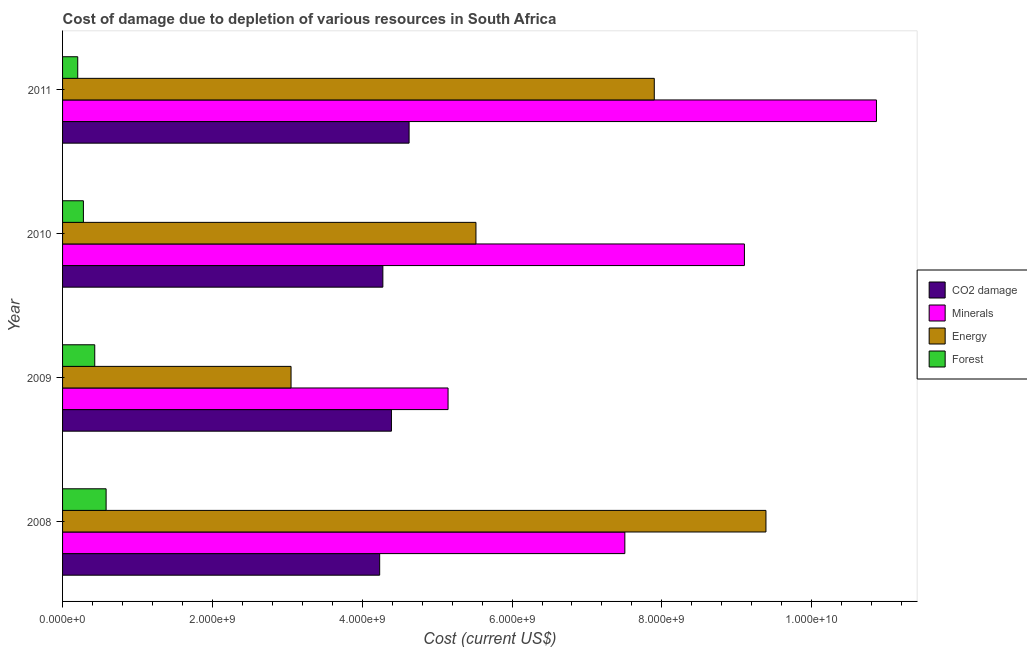How many different coloured bars are there?
Ensure brevity in your answer.  4. How many groups of bars are there?
Provide a short and direct response. 4. Are the number of bars on each tick of the Y-axis equal?
Your answer should be very brief. Yes. In how many cases, is the number of bars for a given year not equal to the number of legend labels?
Provide a short and direct response. 0. What is the cost of damage due to depletion of forests in 2009?
Offer a very short reply. 4.30e+08. Across all years, what is the maximum cost of damage due to depletion of energy?
Ensure brevity in your answer.  9.39e+09. Across all years, what is the minimum cost of damage due to depletion of energy?
Offer a terse response. 3.05e+09. What is the total cost of damage due to depletion of minerals in the graph?
Make the answer very short. 3.26e+1. What is the difference between the cost of damage due to depletion of energy in 2009 and that in 2011?
Offer a very short reply. -4.85e+09. What is the difference between the cost of damage due to depletion of minerals in 2011 and the cost of damage due to depletion of energy in 2008?
Your answer should be very brief. 1.48e+09. What is the average cost of damage due to depletion of minerals per year?
Offer a very short reply. 8.15e+09. In the year 2009, what is the difference between the cost of damage due to depletion of coal and cost of damage due to depletion of energy?
Offer a very short reply. 1.34e+09. In how many years, is the cost of damage due to depletion of energy greater than 1200000000 US$?
Keep it short and to the point. 4. What is the ratio of the cost of damage due to depletion of minerals in 2008 to that in 2011?
Keep it short and to the point. 0.69. What is the difference between the highest and the second highest cost of damage due to depletion of minerals?
Provide a succinct answer. 1.76e+09. What is the difference between the highest and the lowest cost of damage due to depletion of coal?
Your response must be concise. 3.93e+08. In how many years, is the cost of damage due to depletion of forests greater than the average cost of damage due to depletion of forests taken over all years?
Your response must be concise. 2. Is the sum of the cost of damage due to depletion of minerals in 2010 and 2011 greater than the maximum cost of damage due to depletion of energy across all years?
Your answer should be compact. Yes. Is it the case that in every year, the sum of the cost of damage due to depletion of coal and cost of damage due to depletion of minerals is greater than the sum of cost of damage due to depletion of forests and cost of damage due to depletion of energy?
Keep it short and to the point. Yes. What does the 2nd bar from the top in 2011 represents?
Make the answer very short. Energy. What does the 1st bar from the bottom in 2011 represents?
Your answer should be very brief. CO2 damage. Is it the case that in every year, the sum of the cost of damage due to depletion of coal and cost of damage due to depletion of minerals is greater than the cost of damage due to depletion of energy?
Your answer should be very brief. Yes. How many bars are there?
Your answer should be very brief. 16. How many years are there in the graph?
Provide a short and direct response. 4. What is the difference between two consecutive major ticks on the X-axis?
Ensure brevity in your answer.  2.00e+09. Are the values on the major ticks of X-axis written in scientific E-notation?
Offer a very short reply. Yes. Where does the legend appear in the graph?
Make the answer very short. Center right. How are the legend labels stacked?
Your response must be concise. Vertical. What is the title of the graph?
Offer a very short reply. Cost of damage due to depletion of various resources in South Africa . What is the label or title of the X-axis?
Give a very brief answer. Cost (current US$). What is the Cost (current US$) of CO2 damage in 2008?
Offer a very short reply. 4.23e+09. What is the Cost (current US$) of Minerals in 2008?
Your response must be concise. 7.51e+09. What is the Cost (current US$) in Energy in 2008?
Make the answer very short. 9.39e+09. What is the Cost (current US$) of Forest in 2008?
Keep it short and to the point. 5.81e+08. What is the Cost (current US$) of CO2 damage in 2009?
Ensure brevity in your answer.  4.39e+09. What is the Cost (current US$) of Minerals in 2009?
Offer a very short reply. 5.15e+09. What is the Cost (current US$) of Energy in 2009?
Keep it short and to the point. 3.05e+09. What is the Cost (current US$) of Forest in 2009?
Provide a succinct answer. 4.30e+08. What is the Cost (current US$) of CO2 damage in 2010?
Make the answer very short. 4.28e+09. What is the Cost (current US$) in Minerals in 2010?
Your response must be concise. 9.10e+09. What is the Cost (current US$) of Energy in 2010?
Offer a very short reply. 5.52e+09. What is the Cost (current US$) of Forest in 2010?
Your answer should be very brief. 2.78e+08. What is the Cost (current US$) in CO2 damage in 2011?
Provide a short and direct response. 4.63e+09. What is the Cost (current US$) in Minerals in 2011?
Keep it short and to the point. 1.09e+1. What is the Cost (current US$) in Energy in 2011?
Make the answer very short. 7.90e+09. What is the Cost (current US$) in Forest in 2011?
Offer a very short reply. 2.02e+08. Across all years, what is the maximum Cost (current US$) of CO2 damage?
Keep it short and to the point. 4.63e+09. Across all years, what is the maximum Cost (current US$) of Minerals?
Keep it short and to the point. 1.09e+1. Across all years, what is the maximum Cost (current US$) of Energy?
Keep it short and to the point. 9.39e+09. Across all years, what is the maximum Cost (current US$) of Forest?
Your response must be concise. 5.81e+08. Across all years, what is the minimum Cost (current US$) in CO2 damage?
Provide a succinct answer. 4.23e+09. Across all years, what is the minimum Cost (current US$) of Minerals?
Keep it short and to the point. 5.15e+09. Across all years, what is the minimum Cost (current US$) in Energy?
Offer a terse response. 3.05e+09. Across all years, what is the minimum Cost (current US$) of Forest?
Give a very brief answer. 2.02e+08. What is the total Cost (current US$) of CO2 damage in the graph?
Offer a terse response. 1.75e+1. What is the total Cost (current US$) of Minerals in the graph?
Provide a short and direct response. 3.26e+1. What is the total Cost (current US$) in Energy in the graph?
Keep it short and to the point. 2.59e+1. What is the total Cost (current US$) of Forest in the graph?
Make the answer very short. 1.49e+09. What is the difference between the Cost (current US$) in CO2 damage in 2008 and that in 2009?
Your answer should be very brief. -1.57e+08. What is the difference between the Cost (current US$) of Minerals in 2008 and that in 2009?
Offer a very short reply. 2.36e+09. What is the difference between the Cost (current US$) in Energy in 2008 and that in 2009?
Offer a very short reply. 6.34e+09. What is the difference between the Cost (current US$) of Forest in 2008 and that in 2009?
Make the answer very short. 1.52e+08. What is the difference between the Cost (current US$) of CO2 damage in 2008 and that in 2010?
Offer a terse response. -4.26e+07. What is the difference between the Cost (current US$) of Minerals in 2008 and that in 2010?
Give a very brief answer. -1.60e+09. What is the difference between the Cost (current US$) of Energy in 2008 and that in 2010?
Offer a very short reply. 3.87e+09. What is the difference between the Cost (current US$) of Forest in 2008 and that in 2010?
Provide a short and direct response. 3.03e+08. What is the difference between the Cost (current US$) in CO2 damage in 2008 and that in 2011?
Keep it short and to the point. -3.93e+08. What is the difference between the Cost (current US$) in Minerals in 2008 and that in 2011?
Ensure brevity in your answer.  -3.36e+09. What is the difference between the Cost (current US$) of Energy in 2008 and that in 2011?
Provide a succinct answer. 1.49e+09. What is the difference between the Cost (current US$) of Forest in 2008 and that in 2011?
Ensure brevity in your answer.  3.79e+08. What is the difference between the Cost (current US$) in CO2 damage in 2009 and that in 2010?
Your response must be concise. 1.14e+08. What is the difference between the Cost (current US$) of Minerals in 2009 and that in 2010?
Provide a succinct answer. -3.96e+09. What is the difference between the Cost (current US$) in Energy in 2009 and that in 2010?
Your answer should be compact. -2.47e+09. What is the difference between the Cost (current US$) in Forest in 2009 and that in 2010?
Your answer should be very brief. 1.51e+08. What is the difference between the Cost (current US$) of CO2 damage in 2009 and that in 2011?
Give a very brief answer. -2.36e+08. What is the difference between the Cost (current US$) in Minerals in 2009 and that in 2011?
Offer a terse response. -5.72e+09. What is the difference between the Cost (current US$) of Energy in 2009 and that in 2011?
Provide a short and direct response. -4.85e+09. What is the difference between the Cost (current US$) of Forest in 2009 and that in 2011?
Your answer should be compact. 2.27e+08. What is the difference between the Cost (current US$) in CO2 damage in 2010 and that in 2011?
Provide a succinct answer. -3.50e+08. What is the difference between the Cost (current US$) of Minerals in 2010 and that in 2011?
Your answer should be very brief. -1.76e+09. What is the difference between the Cost (current US$) of Energy in 2010 and that in 2011?
Offer a very short reply. -2.38e+09. What is the difference between the Cost (current US$) of Forest in 2010 and that in 2011?
Ensure brevity in your answer.  7.59e+07. What is the difference between the Cost (current US$) of CO2 damage in 2008 and the Cost (current US$) of Minerals in 2009?
Make the answer very short. -9.13e+08. What is the difference between the Cost (current US$) in CO2 damage in 2008 and the Cost (current US$) in Energy in 2009?
Your answer should be very brief. 1.18e+09. What is the difference between the Cost (current US$) in CO2 damage in 2008 and the Cost (current US$) in Forest in 2009?
Your answer should be very brief. 3.80e+09. What is the difference between the Cost (current US$) in Minerals in 2008 and the Cost (current US$) in Energy in 2009?
Ensure brevity in your answer.  4.46e+09. What is the difference between the Cost (current US$) in Minerals in 2008 and the Cost (current US$) in Forest in 2009?
Your response must be concise. 7.08e+09. What is the difference between the Cost (current US$) of Energy in 2008 and the Cost (current US$) of Forest in 2009?
Ensure brevity in your answer.  8.96e+09. What is the difference between the Cost (current US$) of CO2 damage in 2008 and the Cost (current US$) of Minerals in 2010?
Give a very brief answer. -4.87e+09. What is the difference between the Cost (current US$) of CO2 damage in 2008 and the Cost (current US$) of Energy in 2010?
Provide a succinct answer. -1.29e+09. What is the difference between the Cost (current US$) in CO2 damage in 2008 and the Cost (current US$) in Forest in 2010?
Offer a terse response. 3.95e+09. What is the difference between the Cost (current US$) in Minerals in 2008 and the Cost (current US$) in Energy in 2010?
Your answer should be very brief. 1.99e+09. What is the difference between the Cost (current US$) in Minerals in 2008 and the Cost (current US$) in Forest in 2010?
Your answer should be compact. 7.23e+09. What is the difference between the Cost (current US$) of Energy in 2008 and the Cost (current US$) of Forest in 2010?
Offer a terse response. 9.11e+09. What is the difference between the Cost (current US$) of CO2 damage in 2008 and the Cost (current US$) of Minerals in 2011?
Offer a very short reply. -6.63e+09. What is the difference between the Cost (current US$) of CO2 damage in 2008 and the Cost (current US$) of Energy in 2011?
Ensure brevity in your answer.  -3.67e+09. What is the difference between the Cost (current US$) of CO2 damage in 2008 and the Cost (current US$) of Forest in 2011?
Provide a succinct answer. 4.03e+09. What is the difference between the Cost (current US$) in Minerals in 2008 and the Cost (current US$) in Energy in 2011?
Provide a succinct answer. -3.93e+08. What is the difference between the Cost (current US$) in Minerals in 2008 and the Cost (current US$) in Forest in 2011?
Your response must be concise. 7.30e+09. What is the difference between the Cost (current US$) in Energy in 2008 and the Cost (current US$) in Forest in 2011?
Ensure brevity in your answer.  9.19e+09. What is the difference between the Cost (current US$) in CO2 damage in 2009 and the Cost (current US$) in Minerals in 2010?
Your answer should be very brief. -4.71e+09. What is the difference between the Cost (current US$) of CO2 damage in 2009 and the Cost (current US$) of Energy in 2010?
Make the answer very short. -1.13e+09. What is the difference between the Cost (current US$) of CO2 damage in 2009 and the Cost (current US$) of Forest in 2010?
Your response must be concise. 4.11e+09. What is the difference between the Cost (current US$) of Minerals in 2009 and the Cost (current US$) of Energy in 2010?
Give a very brief answer. -3.72e+08. What is the difference between the Cost (current US$) in Minerals in 2009 and the Cost (current US$) in Forest in 2010?
Keep it short and to the point. 4.87e+09. What is the difference between the Cost (current US$) in Energy in 2009 and the Cost (current US$) in Forest in 2010?
Keep it short and to the point. 2.77e+09. What is the difference between the Cost (current US$) in CO2 damage in 2009 and the Cost (current US$) in Minerals in 2011?
Provide a succinct answer. -6.47e+09. What is the difference between the Cost (current US$) of CO2 damage in 2009 and the Cost (current US$) of Energy in 2011?
Make the answer very short. -3.51e+09. What is the difference between the Cost (current US$) in CO2 damage in 2009 and the Cost (current US$) in Forest in 2011?
Ensure brevity in your answer.  4.19e+09. What is the difference between the Cost (current US$) in Minerals in 2009 and the Cost (current US$) in Energy in 2011?
Give a very brief answer. -2.75e+09. What is the difference between the Cost (current US$) in Minerals in 2009 and the Cost (current US$) in Forest in 2011?
Provide a succinct answer. 4.94e+09. What is the difference between the Cost (current US$) of Energy in 2009 and the Cost (current US$) of Forest in 2011?
Give a very brief answer. 2.85e+09. What is the difference between the Cost (current US$) of CO2 damage in 2010 and the Cost (current US$) of Minerals in 2011?
Provide a short and direct response. -6.59e+09. What is the difference between the Cost (current US$) of CO2 damage in 2010 and the Cost (current US$) of Energy in 2011?
Provide a short and direct response. -3.62e+09. What is the difference between the Cost (current US$) of CO2 damage in 2010 and the Cost (current US$) of Forest in 2011?
Your answer should be very brief. 4.07e+09. What is the difference between the Cost (current US$) in Minerals in 2010 and the Cost (current US$) in Energy in 2011?
Make the answer very short. 1.20e+09. What is the difference between the Cost (current US$) in Minerals in 2010 and the Cost (current US$) in Forest in 2011?
Your answer should be very brief. 8.90e+09. What is the difference between the Cost (current US$) in Energy in 2010 and the Cost (current US$) in Forest in 2011?
Ensure brevity in your answer.  5.32e+09. What is the average Cost (current US$) in CO2 damage per year?
Your answer should be compact. 4.38e+09. What is the average Cost (current US$) of Minerals per year?
Provide a succinct answer. 8.15e+09. What is the average Cost (current US$) in Energy per year?
Your answer should be very brief. 6.46e+09. What is the average Cost (current US$) of Forest per year?
Make the answer very short. 3.73e+08. In the year 2008, what is the difference between the Cost (current US$) in CO2 damage and Cost (current US$) in Minerals?
Offer a very short reply. -3.27e+09. In the year 2008, what is the difference between the Cost (current US$) of CO2 damage and Cost (current US$) of Energy?
Provide a short and direct response. -5.16e+09. In the year 2008, what is the difference between the Cost (current US$) of CO2 damage and Cost (current US$) of Forest?
Provide a short and direct response. 3.65e+09. In the year 2008, what is the difference between the Cost (current US$) of Minerals and Cost (current US$) of Energy?
Provide a succinct answer. -1.88e+09. In the year 2008, what is the difference between the Cost (current US$) in Minerals and Cost (current US$) in Forest?
Give a very brief answer. 6.92e+09. In the year 2008, what is the difference between the Cost (current US$) of Energy and Cost (current US$) of Forest?
Offer a very short reply. 8.81e+09. In the year 2009, what is the difference between the Cost (current US$) of CO2 damage and Cost (current US$) of Minerals?
Your response must be concise. -7.56e+08. In the year 2009, what is the difference between the Cost (current US$) in CO2 damage and Cost (current US$) in Energy?
Offer a terse response. 1.34e+09. In the year 2009, what is the difference between the Cost (current US$) of CO2 damage and Cost (current US$) of Forest?
Make the answer very short. 3.96e+09. In the year 2009, what is the difference between the Cost (current US$) of Minerals and Cost (current US$) of Energy?
Your response must be concise. 2.10e+09. In the year 2009, what is the difference between the Cost (current US$) in Minerals and Cost (current US$) in Forest?
Give a very brief answer. 4.72e+09. In the year 2009, what is the difference between the Cost (current US$) of Energy and Cost (current US$) of Forest?
Keep it short and to the point. 2.62e+09. In the year 2010, what is the difference between the Cost (current US$) in CO2 damage and Cost (current US$) in Minerals?
Offer a terse response. -4.83e+09. In the year 2010, what is the difference between the Cost (current US$) in CO2 damage and Cost (current US$) in Energy?
Give a very brief answer. -1.24e+09. In the year 2010, what is the difference between the Cost (current US$) in CO2 damage and Cost (current US$) in Forest?
Offer a very short reply. 4.00e+09. In the year 2010, what is the difference between the Cost (current US$) of Minerals and Cost (current US$) of Energy?
Your answer should be very brief. 3.58e+09. In the year 2010, what is the difference between the Cost (current US$) of Minerals and Cost (current US$) of Forest?
Keep it short and to the point. 8.82e+09. In the year 2010, what is the difference between the Cost (current US$) in Energy and Cost (current US$) in Forest?
Provide a succinct answer. 5.24e+09. In the year 2011, what is the difference between the Cost (current US$) of CO2 damage and Cost (current US$) of Minerals?
Give a very brief answer. -6.24e+09. In the year 2011, what is the difference between the Cost (current US$) in CO2 damage and Cost (current US$) in Energy?
Ensure brevity in your answer.  -3.27e+09. In the year 2011, what is the difference between the Cost (current US$) of CO2 damage and Cost (current US$) of Forest?
Provide a short and direct response. 4.42e+09. In the year 2011, what is the difference between the Cost (current US$) of Minerals and Cost (current US$) of Energy?
Keep it short and to the point. 2.97e+09. In the year 2011, what is the difference between the Cost (current US$) in Minerals and Cost (current US$) in Forest?
Your answer should be compact. 1.07e+1. In the year 2011, what is the difference between the Cost (current US$) in Energy and Cost (current US$) in Forest?
Your answer should be very brief. 7.70e+09. What is the ratio of the Cost (current US$) of CO2 damage in 2008 to that in 2009?
Provide a short and direct response. 0.96. What is the ratio of the Cost (current US$) of Minerals in 2008 to that in 2009?
Ensure brevity in your answer.  1.46. What is the ratio of the Cost (current US$) of Energy in 2008 to that in 2009?
Provide a succinct answer. 3.08. What is the ratio of the Cost (current US$) in Forest in 2008 to that in 2009?
Keep it short and to the point. 1.35. What is the ratio of the Cost (current US$) in Minerals in 2008 to that in 2010?
Your response must be concise. 0.82. What is the ratio of the Cost (current US$) of Energy in 2008 to that in 2010?
Your answer should be very brief. 1.7. What is the ratio of the Cost (current US$) of Forest in 2008 to that in 2010?
Make the answer very short. 2.09. What is the ratio of the Cost (current US$) in CO2 damage in 2008 to that in 2011?
Provide a short and direct response. 0.92. What is the ratio of the Cost (current US$) of Minerals in 2008 to that in 2011?
Provide a succinct answer. 0.69. What is the ratio of the Cost (current US$) in Energy in 2008 to that in 2011?
Offer a terse response. 1.19. What is the ratio of the Cost (current US$) in Forest in 2008 to that in 2011?
Keep it short and to the point. 2.87. What is the ratio of the Cost (current US$) of CO2 damage in 2009 to that in 2010?
Provide a succinct answer. 1.03. What is the ratio of the Cost (current US$) in Minerals in 2009 to that in 2010?
Offer a very short reply. 0.57. What is the ratio of the Cost (current US$) in Energy in 2009 to that in 2010?
Give a very brief answer. 0.55. What is the ratio of the Cost (current US$) in Forest in 2009 to that in 2010?
Make the answer very short. 1.54. What is the ratio of the Cost (current US$) of CO2 damage in 2009 to that in 2011?
Keep it short and to the point. 0.95. What is the ratio of the Cost (current US$) in Minerals in 2009 to that in 2011?
Provide a short and direct response. 0.47. What is the ratio of the Cost (current US$) of Energy in 2009 to that in 2011?
Your answer should be compact. 0.39. What is the ratio of the Cost (current US$) of Forest in 2009 to that in 2011?
Your answer should be very brief. 2.12. What is the ratio of the Cost (current US$) in CO2 damage in 2010 to that in 2011?
Make the answer very short. 0.92. What is the ratio of the Cost (current US$) of Minerals in 2010 to that in 2011?
Offer a very short reply. 0.84. What is the ratio of the Cost (current US$) in Energy in 2010 to that in 2011?
Ensure brevity in your answer.  0.7. What is the ratio of the Cost (current US$) in Forest in 2010 to that in 2011?
Offer a very short reply. 1.37. What is the difference between the highest and the second highest Cost (current US$) in CO2 damage?
Offer a very short reply. 2.36e+08. What is the difference between the highest and the second highest Cost (current US$) of Minerals?
Your answer should be very brief. 1.76e+09. What is the difference between the highest and the second highest Cost (current US$) in Energy?
Keep it short and to the point. 1.49e+09. What is the difference between the highest and the second highest Cost (current US$) in Forest?
Offer a terse response. 1.52e+08. What is the difference between the highest and the lowest Cost (current US$) of CO2 damage?
Your answer should be very brief. 3.93e+08. What is the difference between the highest and the lowest Cost (current US$) in Minerals?
Your answer should be compact. 5.72e+09. What is the difference between the highest and the lowest Cost (current US$) of Energy?
Give a very brief answer. 6.34e+09. What is the difference between the highest and the lowest Cost (current US$) in Forest?
Provide a short and direct response. 3.79e+08. 